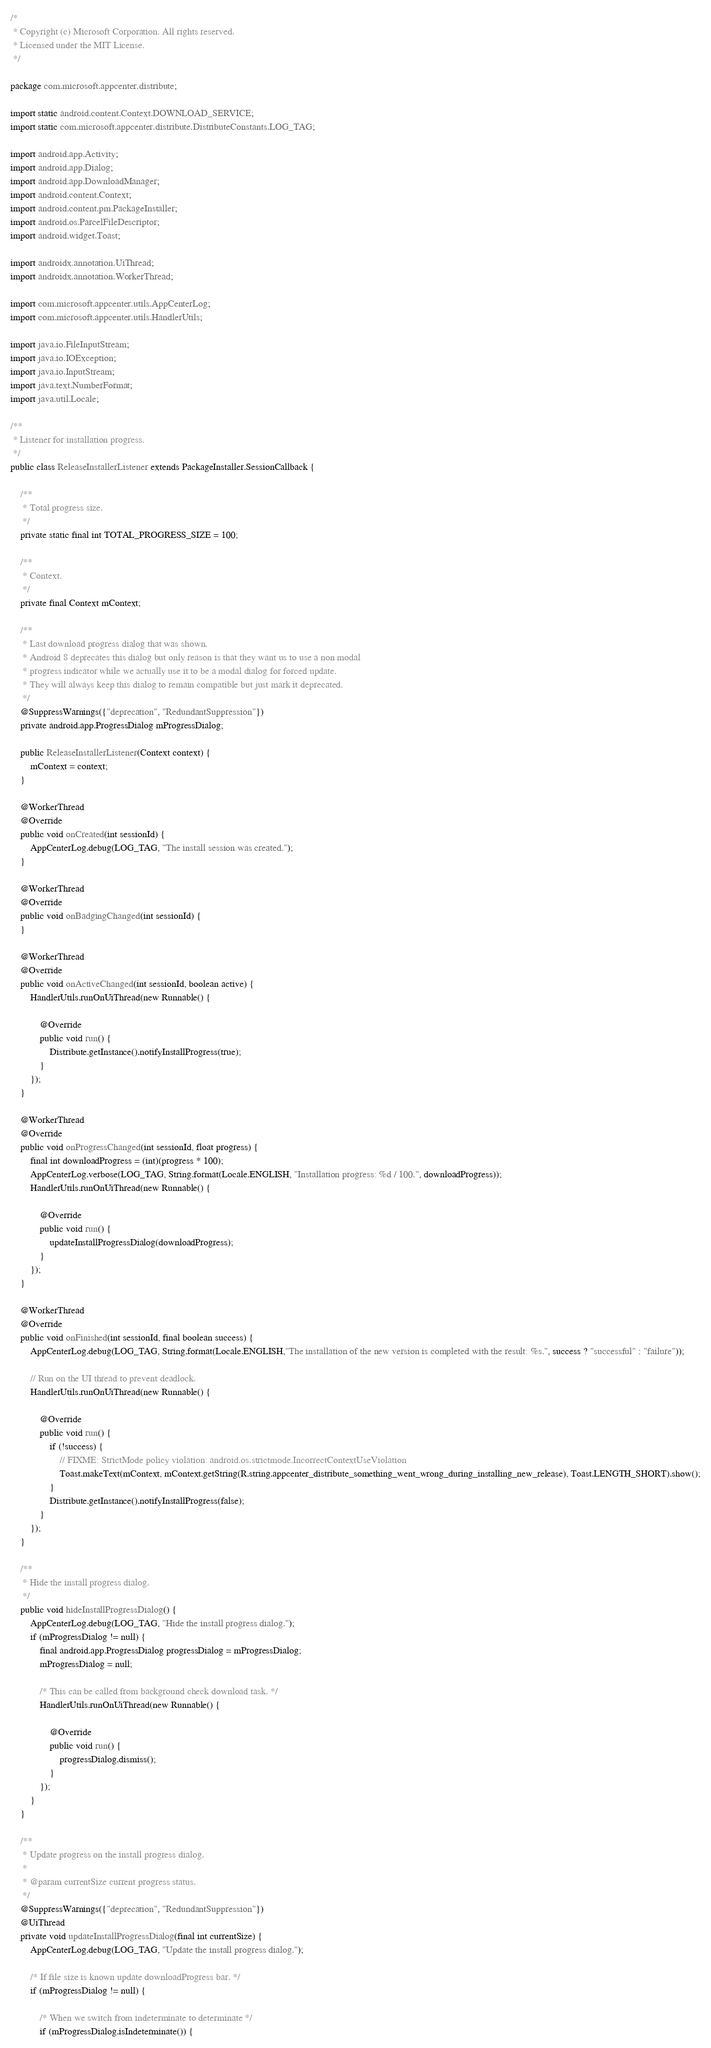<code> <loc_0><loc_0><loc_500><loc_500><_Java_>/*
 * Copyright (c) Microsoft Corporation. All rights reserved.
 * Licensed under the MIT License.
 */

package com.microsoft.appcenter.distribute;

import static android.content.Context.DOWNLOAD_SERVICE;
import static com.microsoft.appcenter.distribute.DistributeConstants.LOG_TAG;

import android.app.Activity;
import android.app.Dialog;
import android.app.DownloadManager;
import android.content.Context;
import android.content.pm.PackageInstaller;
import android.os.ParcelFileDescriptor;
import android.widget.Toast;

import androidx.annotation.UiThread;
import androidx.annotation.WorkerThread;

import com.microsoft.appcenter.utils.AppCenterLog;
import com.microsoft.appcenter.utils.HandlerUtils;

import java.io.FileInputStream;
import java.io.IOException;
import java.io.InputStream;
import java.text.NumberFormat;
import java.util.Locale;

/**
 * Listener for installation progress.
 */
public class ReleaseInstallerListener extends PackageInstaller.SessionCallback {

    /**
     * Total progress size.
     */
    private static final int TOTAL_PROGRESS_SIZE = 100;

    /**
     * Context.
     */
    private final Context mContext;

    /**
     * Last download progress dialog that was shown.
     * Android 8 deprecates this dialog but only reason is that they want us to use a non modal
     * progress indicator while we actually use it to be a modal dialog for forced update.
     * They will always keep this dialog to remain compatible but just mark it deprecated.
     */
    @SuppressWarnings({"deprecation", "RedundantSuppression"})
    private android.app.ProgressDialog mProgressDialog;

    public ReleaseInstallerListener(Context context) {
        mContext = context;
    }

    @WorkerThread
    @Override
    public void onCreated(int sessionId) {
        AppCenterLog.debug(LOG_TAG, "The install session was created.");
    }

    @WorkerThread
    @Override
    public void onBadgingChanged(int sessionId) {
    }

    @WorkerThread
    @Override
    public void onActiveChanged(int sessionId, boolean active) {
        HandlerUtils.runOnUiThread(new Runnable() {

            @Override
            public void run() {
                Distribute.getInstance().notifyInstallProgress(true);
            }
        });
    }

    @WorkerThread
    @Override
    public void onProgressChanged(int sessionId, float progress) {
        final int downloadProgress = (int)(progress * 100);
        AppCenterLog.verbose(LOG_TAG, String.format(Locale.ENGLISH, "Installation progress: %d / 100.", downloadProgress));
        HandlerUtils.runOnUiThread(new Runnable() {

            @Override
            public void run() {
                updateInstallProgressDialog(downloadProgress);
            }
        });
    }

    @WorkerThread
    @Override
    public void onFinished(int sessionId, final boolean success) {
        AppCenterLog.debug(LOG_TAG, String.format(Locale.ENGLISH,"The installation of the new version is completed with the result: %s.", success ? "successful" : "failure"));

        // Run on the UI thread to prevent deadlock.
        HandlerUtils.runOnUiThread(new Runnable() {

            @Override
            public void run() {
                if (!success) {
                    // FIXME: StrictMode policy violation: android.os.strictmode.IncorrectContextUseViolation
                    Toast.makeText(mContext, mContext.getString(R.string.appcenter_distribute_something_went_wrong_during_installing_new_release), Toast.LENGTH_SHORT).show();
                }
                Distribute.getInstance().notifyInstallProgress(false);
            }
        });
    }

    /**
     * Hide the install progress dialog.
     */
    public void hideInstallProgressDialog() {
        AppCenterLog.debug(LOG_TAG, "Hide the install progress dialog.");
        if (mProgressDialog != null) {
            final android.app.ProgressDialog progressDialog = mProgressDialog;
            mProgressDialog = null;

            /* This can be called from background check download task. */
            HandlerUtils.runOnUiThread(new Runnable() {

                @Override
                public void run() {
                    progressDialog.dismiss();
                }
            });
        }
    }

    /**
     * Update progress on the install progress dialog.
     *
     * @param currentSize current progress status.
     */
    @SuppressWarnings({"deprecation", "RedundantSuppression"})
    @UiThread
    private void updateInstallProgressDialog(final int currentSize) {
        AppCenterLog.debug(LOG_TAG, "Update the install progress dialog.");

        /* If file size is known update downloadProgress bar. */
        if (mProgressDialog != null) {

            /* When we switch from indeterminate to determinate */
            if (mProgressDialog.isIndeterminate()) {
</code> 